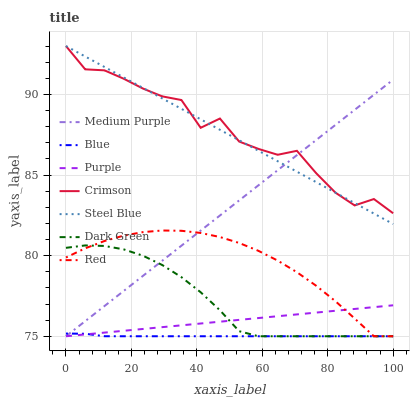Does Blue have the minimum area under the curve?
Answer yes or no. Yes. Does Crimson have the maximum area under the curve?
Answer yes or no. Yes. Does Purple have the minimum area under the curve?
Answer yes or no. No. Does Purple have the maximum area under the curve?
Answer yes or no. No. Is Medium Purple the smoothest?
Answer yes or no. Yes. Is Crimson the roughest?
Answer yes or no. Yes. Is Purple the smoothest?
Answer yes or no. No. Is Purple the roughest?
Answer yes or no. No. Does Blue have the lowest value?
Answer yes or no. Yes. Does Steel Blue have the lowest value?
Answer yes or no. No. Does Crimson have the highest value?
Answer yes or no. Yes. Does Purple have the highest value?
Answer yes or no. No. Is Red less than Crimson?
Answer yes or no. Yes. Is Crimson greater than Red?
Answer yes or no. Yes. Does Red intersect Medium Purple?
Answer yes or no. Yes. Is Red less than Medium Purple?
Answer yes or no. No. Is Red greater than Medium Purple?
Answer yes or no. No. Does Red intersect Crimson?
Answer yes or no. No. 